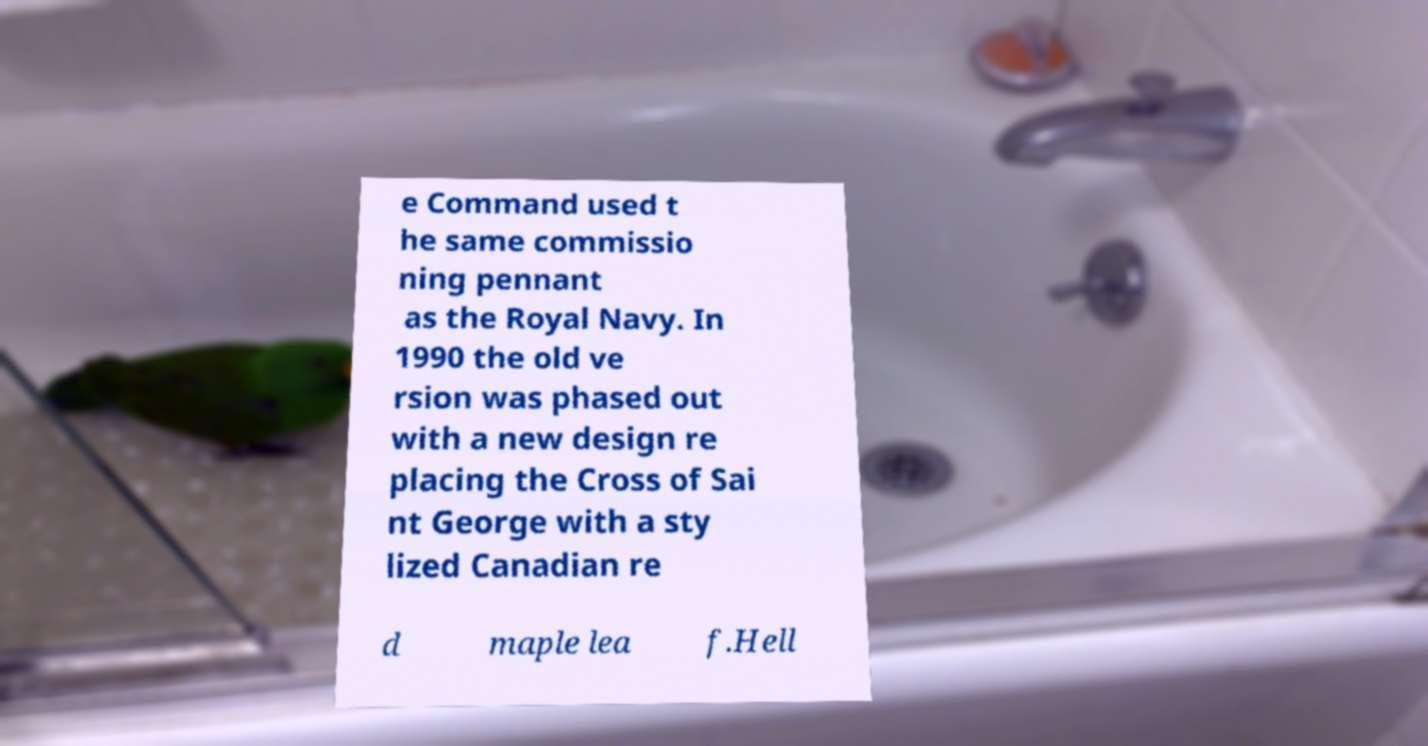Can you read and provide the text displayed in the image?This photo seems to have some interesting text. Can you extract and type it out for me? e Command used t he same commissio ning pennant as the Royal Navy. In 1990 the old ve rsion was phased out with a new design re placing the Cross of Sai nt George with a sty lized Canadian re d maple lea f.Hell 